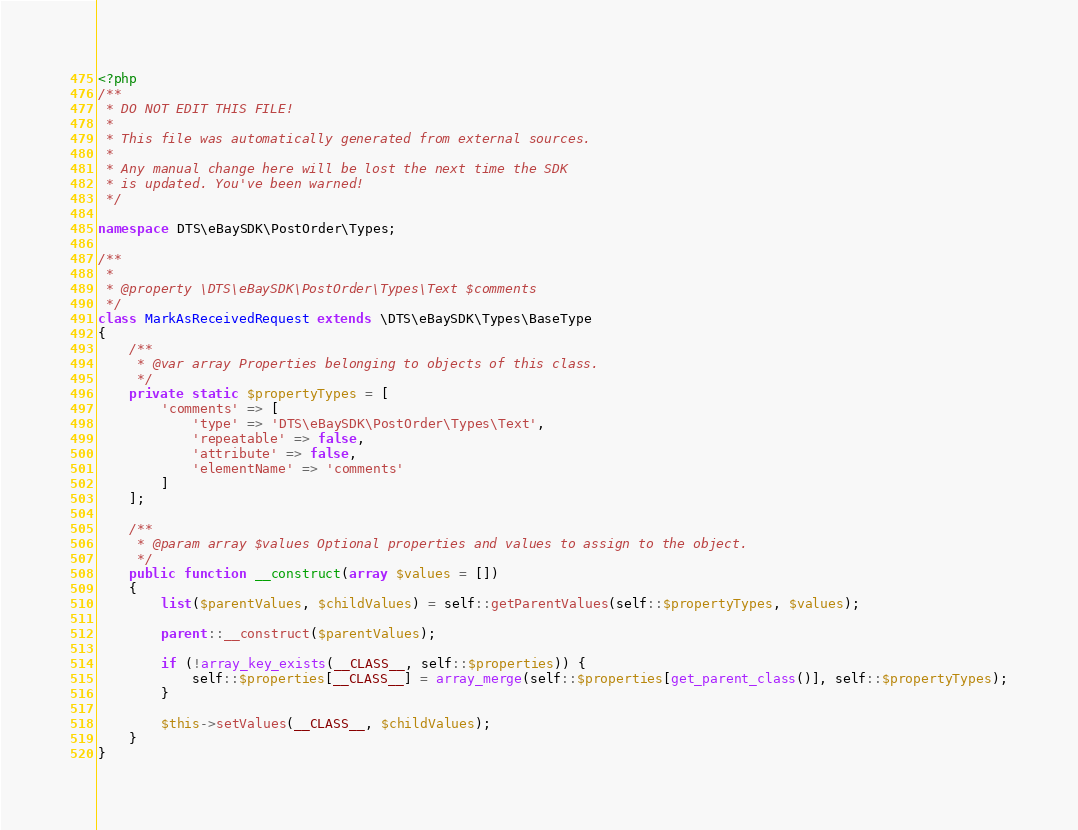<code> <loc_0><loc_0><loc_500><loc_500><_PHP_><?php
/**
 * DO NOT EDIT THIS FILE!
 *
 * This file was automatically generated from external sources.
 *
 * Any manual change here will be lost the next time the SDK
 * is updated. You've been warned!
 */

namespace DTS\eBaySDK\PostOrder\Types;

/**
 *
 * @property \DTS\eBaySDK\PostOrder\Types\Text $comments
 */
class MarkAsReceivedRequest extends \DTS\eBaySDK\Types\BaseType
{
    /**
     * @var array Properties belonging to objects of this class.
     */
    private static $propertyTypes = [
        'comments' => [
            'type' => 'DTS\eBaySDK\PostOrder\Types\Text',
            'repeatable' => false,
            'attribute' => false,
            'elementName' => 'comments'
        ]
    ];

    /**
     * @param array $values Optional properties and values to assign to the object.
     */
    public function __construct(array $values = [])
    {
        list($parentValues, $childValues) = self::getParentValues(self::$propertyTypes, $values);

        parent::__construct($parentValues);

        if (!array_key_exists(__CLASS__, self::$properties)) {
            self::$properties[__CLASS__] = array_merge(self::$properties[get_parent_class()], self::$propertyTypes);
        }

        $this->setValues(__CLASS__, $childValues);
    }
}
</code> 